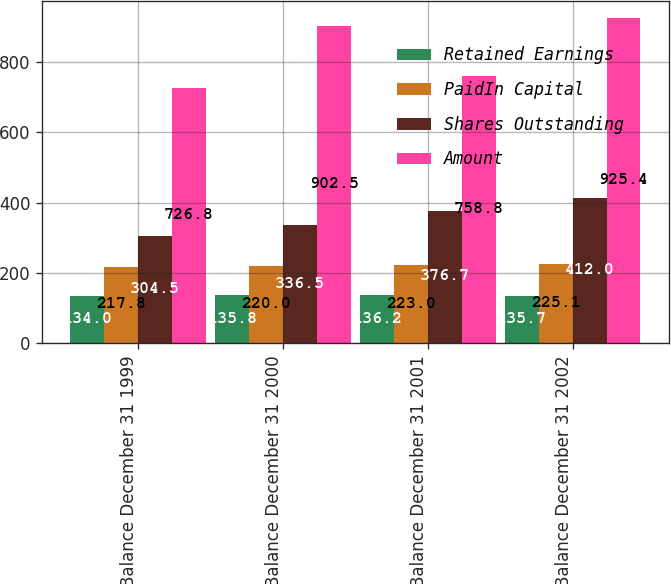Convert chart to OTSL. <chart><loc_0><loc_0><loc_500><loc_500><stacked_bar_chart><ecel><fcel>Balance December 31 1999<fcel>Balance December 31 2000<fcel>Balance December 31 2001<fcel>Balance December 31 2002<nl><fcel>Retained Earnings<fcel>134<fcel>135.8<fcel>136.2<fcel>135.7<nl><fcel>PaidIn Capital<fcel>217.8<fcel>220<fcel>223<fcel>225.1<nl><fcel>Shares Outstanding<fcel>304.5<fcel>336.5<fcel>376.7<fcel>412<nl><fcel>Amount<fcel>726.8<fcel>902.5<fcel>758.8<fcel>925.4<nl></chart> 